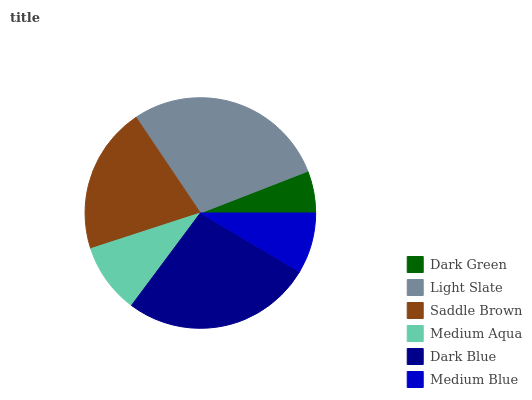Is Dark Green the minimum?
Answer yes or no. Yes. Is Light Slate the maximum?
Answer yes or no. Yes. Is Saddle Brown the minimum?
Answer yes or no. No. Is Saddle Brown the maximum?
Answer yes or no. No. Is Light Slate greater than Saddle Brown?
Answer yes or no. Yes. Is Saddle Brown less than Light Slate?
Answer yes or no. Yes. Is Saddle Brown greater than Light Slate?
Answer yes or no. No. Is Light Slate less than Saddle Brown?
Answer yes or no. No. Is Saddle Brown the high median?
Answer yes or no. Yes. Is Medium Aqua the low median?
Answer yes or no. Yes. Is Light Slate the high median?
Answer yes or no. No. Is Medium Blue the low median?
Answer yes or no. No. 